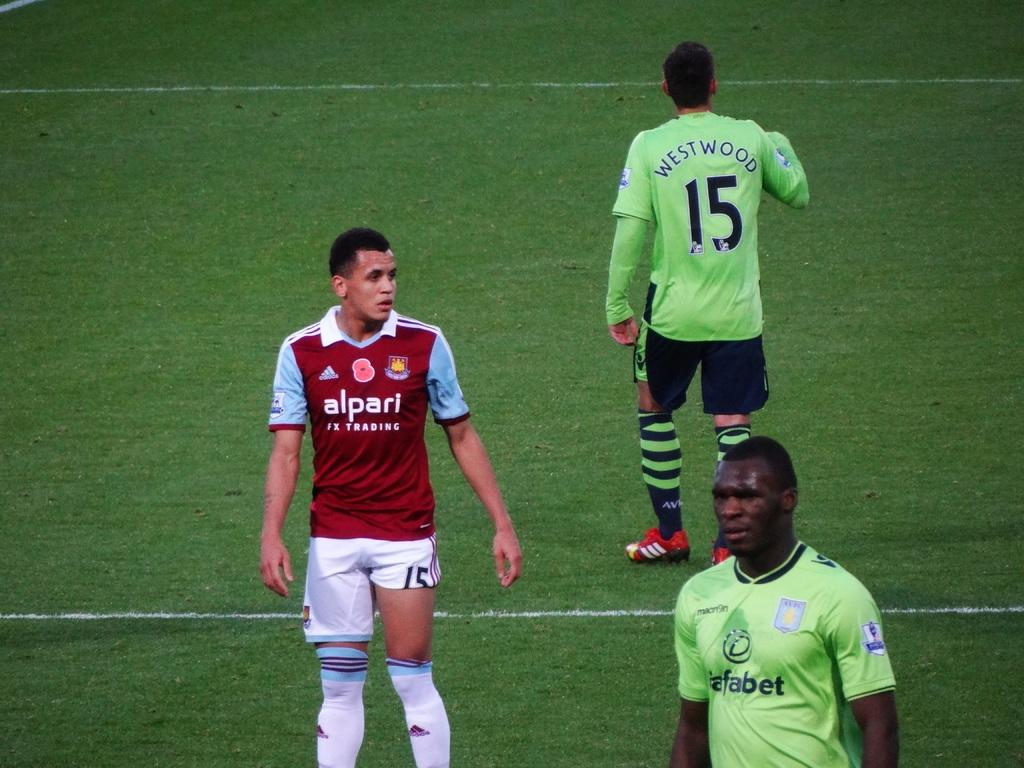<image>
Relay a brief, clear account of the picture shown. Soccer players on the field including one named Westwood. 